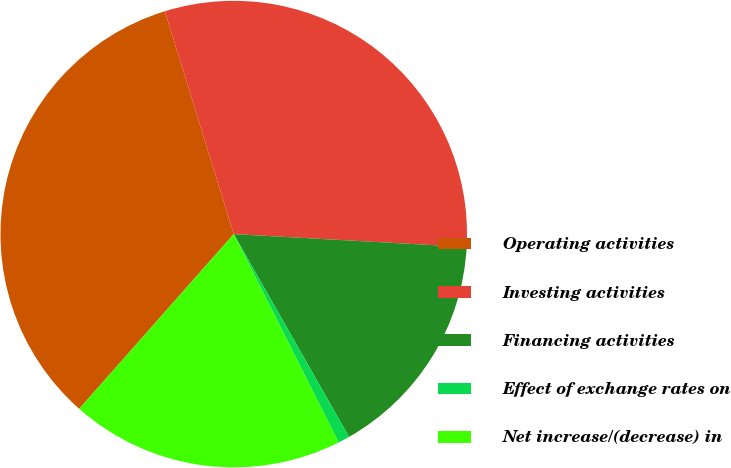Convert chart. <chart><loc_0><loc_0><loc_500><loc_500><pie_chart><fcel>Operating activities<fcel>Investing activities<fcel>Financing activities<fcel>Effect of exchange rates on<fcel>Net increase/(decrease) in<nl><fcel>33.7%<fcel>30.65%<fcel>15.89%<fcel>0.81%<fcel>18.94%<nl></chart> 